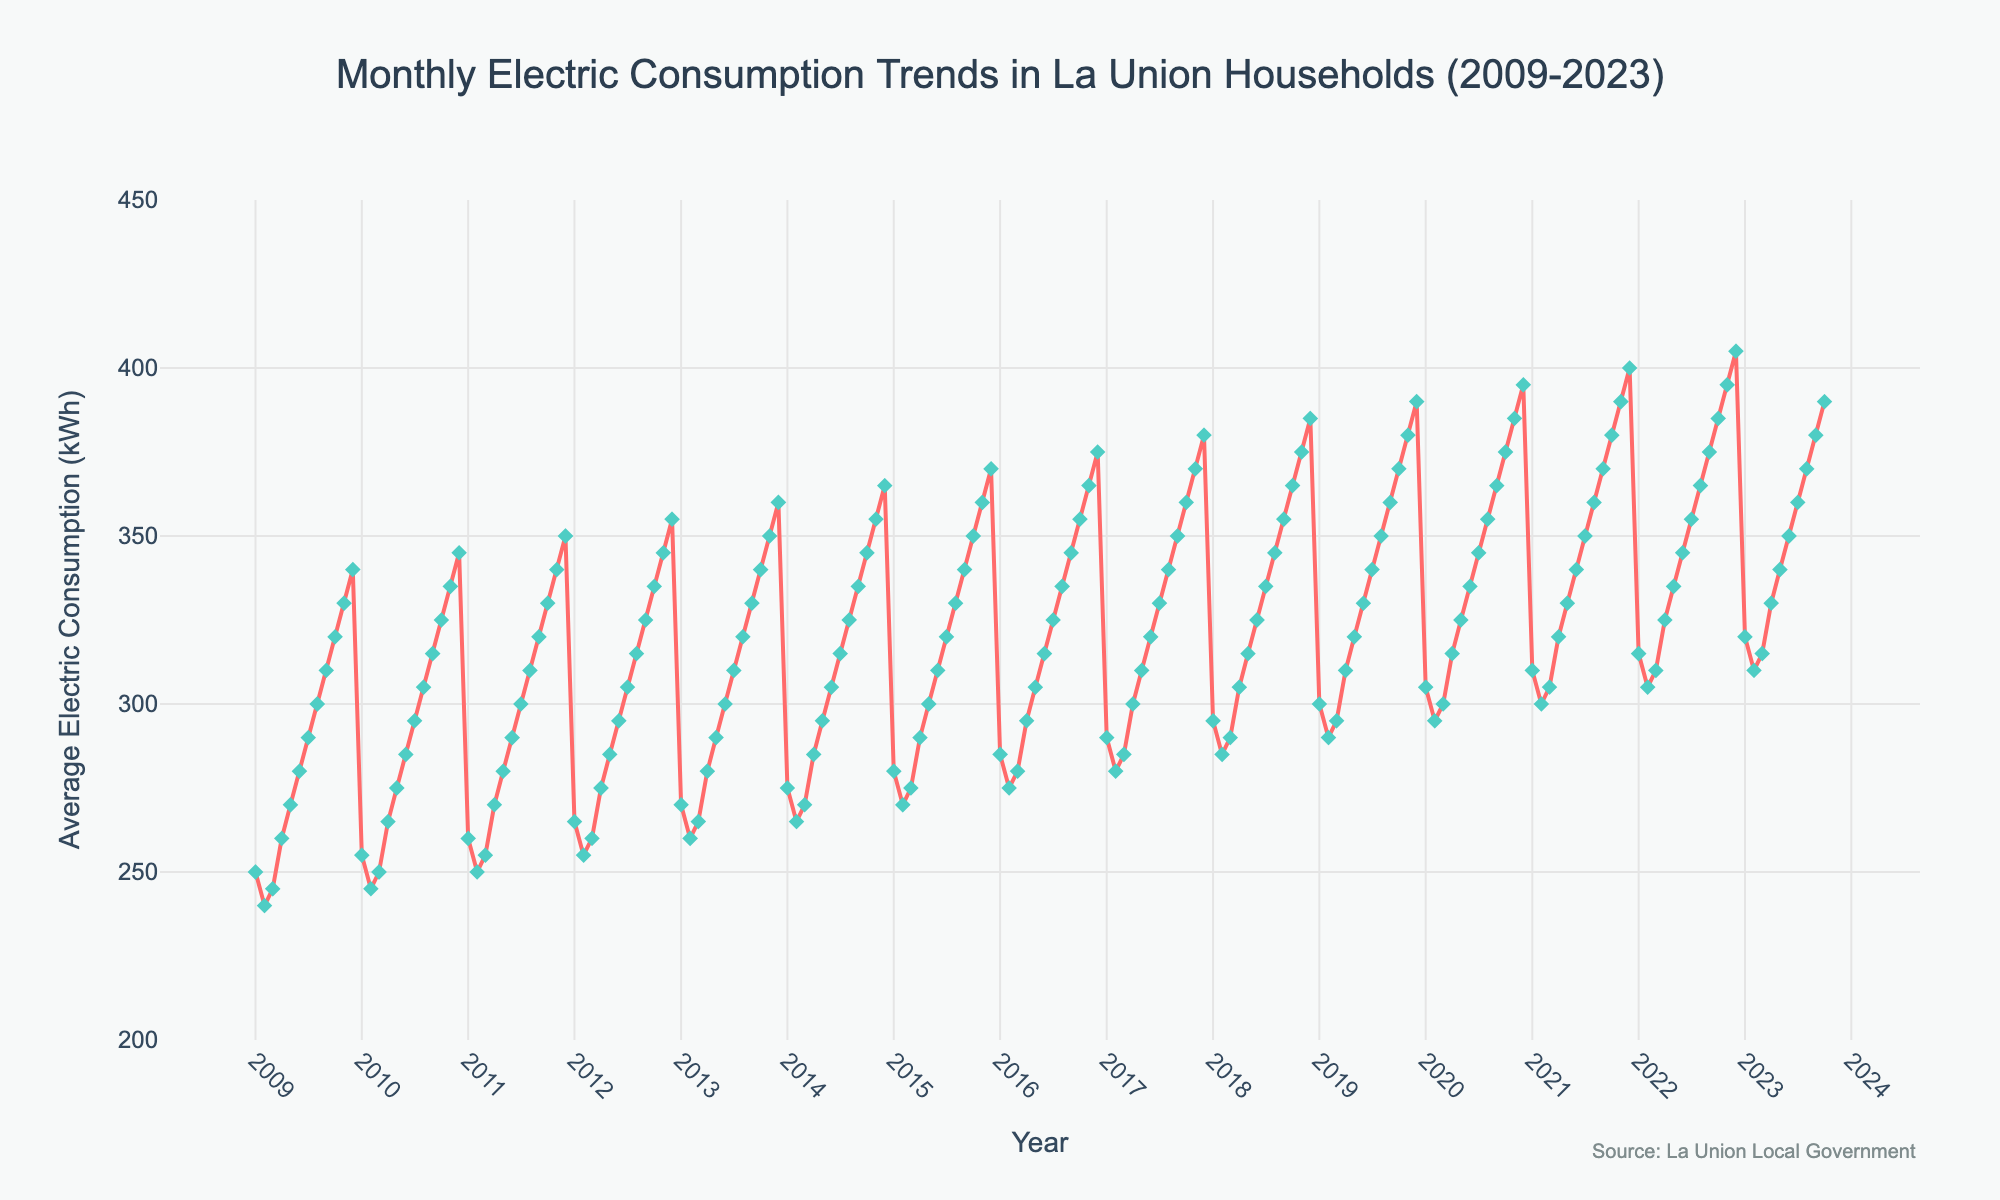How many years are covered by the time series plot? The title states that the data spans from 2009 to 2023. To confirm, we count the number of ticks on the x-axis from 2009 to 2023.
Answer: 15 years What is the average electric consumption in August 2018? Locate the data point for August 2018 on the time series plot. The y-axis value for August 2018 can be read directly.
Answer: 345 kWh Over the entire period displayed in the plot, which month shows the highest average electric consumption? Inspect the data points to identify the month with the highest y-axis value. The highest consumption is in December 2022.
Answer: December 2022 Which year had the highest increase in average electric consumption from January to December? Calculate the difference in electric consumption between January and December for each year and compare. 2022 had the highest increase as it went from 315 kWh in January to 405 kWh in December, an increase of 90 kWh.
Answer: 2022 What is the range of average electric consumption values shown in the figure? The range is found by subtracting the minimum value from the maximum value. The minimum value is 240 kWh and the maximum is 405 kWh, resulting in a range.
Answer: 165 kWh Compare the average electric consumption in July of 2011 and July of 2023. Locate the data points for July 2011 and July 2023. Read the y-axis values and compare: 300 kWh for 2011 and 360 kWh for 2023.
Answer: 60 kWh more in 2023 Which month and year had a lower average consumption, March 2010 or March 2020? Locate the data points for March 2010 and March 2020. Compare the y-axis values: 250 kWh in March 2010 and 300 kWh in March 2020.
Answer: March 2010 What is the overall trend in average electric consumption from 2009 to 2023? Observe the general direction of the data points on the plot. The trend is an overall increase from about 250 kWh to nearly 390 kWh.
Answer: Increasing trend How much did the average consumption increase from May to June in the year 2015? Locate the data points for May and June 2015, then subtract the y-axis value of May (300 kWh) from that of June (310 kWh).
Answer: 10 kWh Is there a seasonal pattern in the electric consumption data? Examine the plot to see if there's a recurring pattern in the consumption values for specific months each year. Consumption generally increases in December and dips around February, indicating a seasonal pattern.
Answer: Yes, seasonal pattern observed 